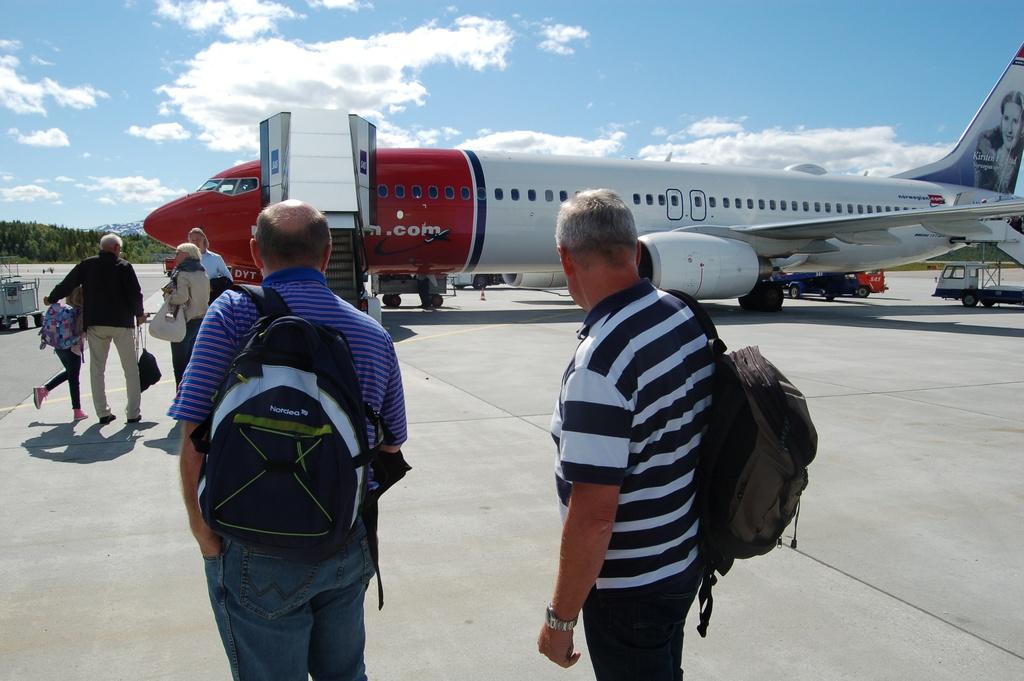What kind of backpack is the man in the striped shirt wearing?
Your answer should be very brief. Unanswerable. 